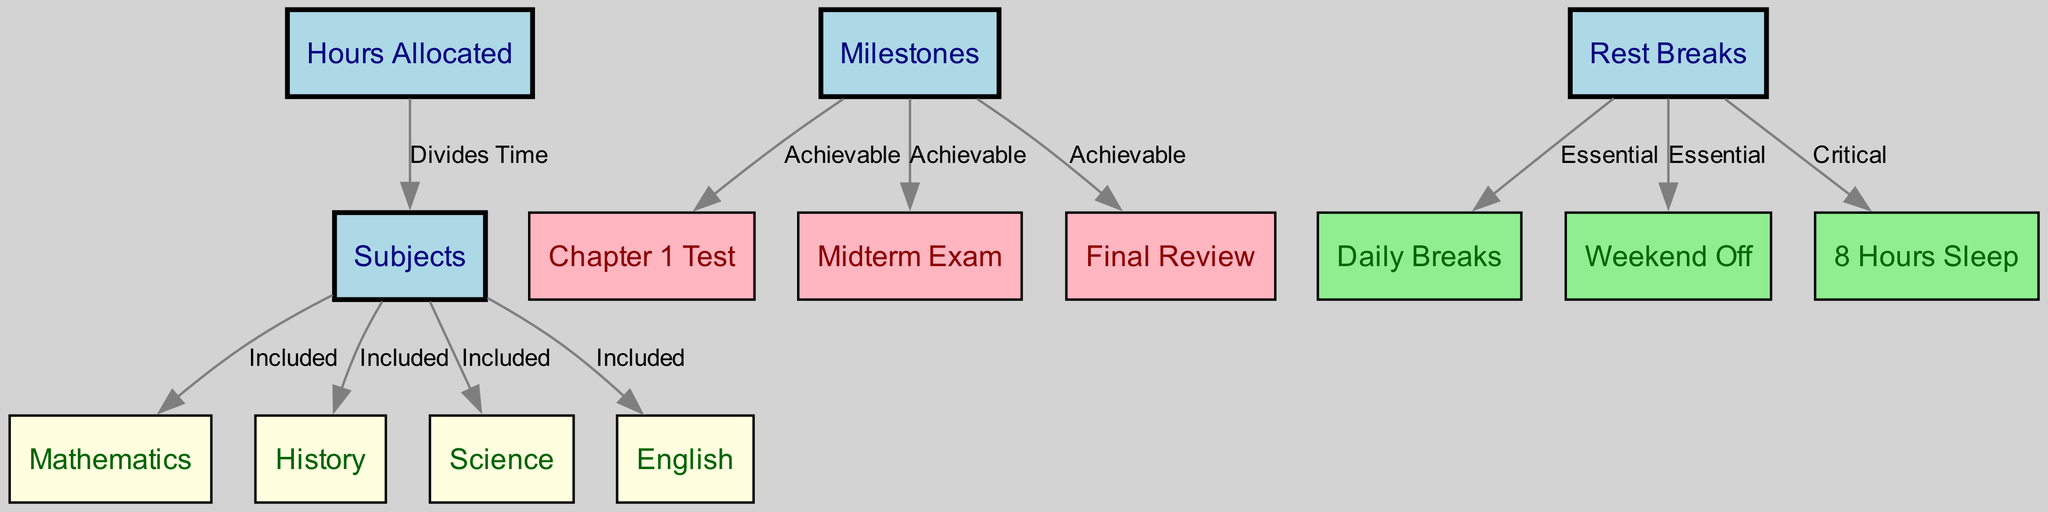What is the total number of subjects listed? The diagram includes four specific subjects identified as Mathematics, History, Science, and English. Counting these, we find that there are four subjects in total.
Answer: 4 How are the hours allocated related to the subjects? The edge connecting "Hours Allocated" to "Subjects" indicates that the allocation of study time is what divides time among the various subjects. This shows the relationship of time management to subject focus in the study plan.
Answer: Divides Time Which milestone is associated with the midterm exam? The edge connecting "Milestones" to "Midterm Exam" specifies that the midterm exam is one of the achievable milestones in the study plan, showing its significance in assessments.
Answer: Achievable What is critical according to the rest breaks? The edge from "Rest Breaks" to "Sleep Hours" indicates that proper sleep is deemed critical for effective study and overall health, emphasizing the necessity of rest for a student's performance.
Answer: Critical What color represents the subjects in the diagram? The nodes representing subjects such as Mathematics, History, Science, and English are filled with light yellow color, which distinguishes them from other parts of the diagram.
Answer: Light Yellow Which subjects are included in the study planner? The subjects listed in the diagram specifically include Mathematics, History, Science, and English, as indicated by the edges connecting "Subjects" to these individual nodes.
Answer: Mathematics, History, Science, English What breaks are considered essential in the study planner? The diagram shows edges from "Rest Breaks" to "Daily Breaks" and "Weekend Off," indicating that both daily breaks and weekend offs are essential for effective studying.
Answer: Daily Breaks, Weekend Off What is the relationship between rest breaks and daily breaks? The edge labeled "Essential" shows a direct connection between "Rest Breaks" and "Daily Breaks," suggesting that daily breaks are a fundamental component of the overall rest breaks strategy in the study plan.
Answer: Essential How many milestones are achievable according to the diagram? The diagram specifies three achievable milestones: Chapter 1 Test, Midterm Exam, and Final Review, giving a clear count of the milestones outlined in the study planner.
Answer: 3 